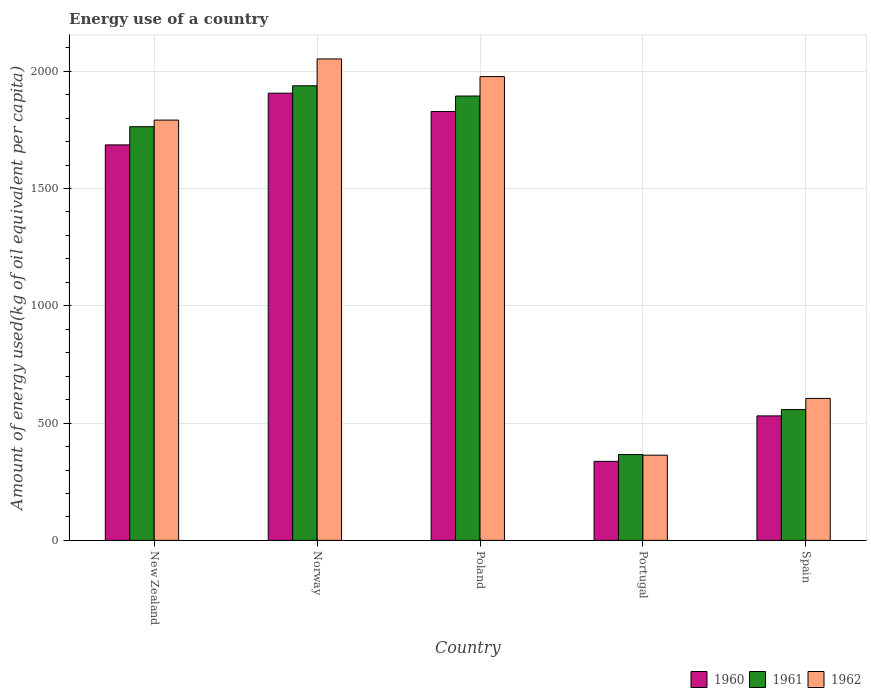How many different coloured bars are there?
Offer a terse response. 3. How many groups of bars are there?
Your answer should be very brief. 5. Are the number of bars per tick equal to the number of legend labels?
Keep it short and to the point. Yes. How many bars are there on the 1st tick from the right?
Give a very brief answer. 3. What is the label of the 4th group of bars from the left?
Offer a very short reply. Portugal. What is the amount of energy used in in 1962 in Poland?
Offer a terse response. 1976.86. Across all countries, what is the maximum amount of energy used in in 1960?
Your response must be concise. 1906.17. Across all countries, what is the minimum amount of energy used in in 1962?
Offer a very short reply. 363.16. In which country was the amount of energy used in in 1961 maximum?
Provide a succinct answer. Norway. In which country was the amount of energy used in in 1961 minimum?
Your answer should be very brief. Portugal. What is the total amount of energy used in in 1962 in the graph?
Keep it short and to the point. 6788.76. What is the difference between the amount of energy used in in 1961 in Norway and that in Spain?
Give a very brief answer. 1380.05. What is the difference between the amount of energy used in in 1962 in Norway and the amount of energy used in in 1960 in New Zealand?
Your response must be concise. 366.27. What is the average amount of energy used in in 1961 per country?
Offer a very short reply. 1303.68. What is the difference between the amount of energy used in of/in 1962 and amount of energy used in of/in 1960 in New Zealand?
Provide a succinct answer. 105.67. In how many countries, is the amount of energy used in in 1961 greater than 1000 kg?
Ensure brevity in your answer.  3. What is the ratio of the amount of energy used in in 1961 in New Zealand to that in Portugal?
Your response must be concise. 4.82. Is the amount of energy used in in 1960 in New Zealand less than that in Portugal?
Your answer should be very brief. No. What is the difference between the highest and the second highest amount of energy used in in 1961?
Your response must be concise. 174.38. What is the difference between the highest and the lowest amount of energy used in in 1961?
Offer a terse response. 1571.8. In how many countries, is the amount of energy used in in 1960 greater than the average amount of energy used in in 1960 taken over all countries?
Offer a terse response. 3. Is the sum of the amount of energy used in in 1962 in New Zealand and Poland greater than the maximum amount of energy used in in 1960 across all countries?
Provide a short and direct response. Yes. Are all the bars in the graph horizontal?
Provide a succinct answer. No. What is the difference between two consecutive major ticks on the Y-axis?
Offer a very short reply. 500. Are the values on the major ticks of Y-axis written in scientific E-notation?
Offer a terse response. No. Does the graph contain any zero values?
Offer a terse response. No. What is the title of the graph?
Your response must be concise. Energy use of a country. Does "1975" appear as one of the legend labels in the graph?
Keep it short and to the point. No. What is the label or title of the X-axis?
Your response must be concise. Country. What is the label or title of the Y-axis?
Offer a terse response. Amount of energy used(kg of oil equivalent per capita). What is the Amount of energy used(kg of oil equivalent per capita) of 1960 in New Zealand?
Your answer should be very brief. 1685.79. What is the Amount of energy used(kg of oil equivalent per capita) of 1961 in New Zealand?
Offer a terse response. 1763.26. What is the Amount of energy used(kg of oil equivalent per capita) of 1962 in New Zealand?
Make the answer very short. 1791.46. What is the Amount of energy used(kg of oil equivalent per capita) of 1960 in Norway?
Provide a short and direct response. 1906.17. What is the Amount of energy used(kg of oil equivalent per capita) of 1961 in Norway?
Provide a succinct answer. 1937.64. What is the Amount of energy used(kg of oil equivalent per capita) of 1962 in Norway?
Make the answer very short. 2052.05. What is the Amount of energy used(kg of oil equivalent per capita) of 1960 in Poland?
Your answer should be compact. 1827.94. What is the Amount of energy used(kg of oil equivalent per capita) of 1961 in Poland?
Your answer should be compact. 1894.06. What is the Amount of energy used(kg of oil equivalent per capita) of 1962 in Poland?
Keep it short and to the point. 1976.86. What is the Amount of energy used(kg of oil equivalent per capita) in 1960 in Portugal?
Offer a terse response. 336.91. What is the Amount of energy used(kg of oil equivalent per capita) of 1961 in Portugal?
Make the answer very short. 365.84. What is the Amount of energy used(kg of oil equivalent per capita) in 1962 in Portugal?
Your answer should be compact. 363.16. What is the Amount of energy used(kg of oil equivalent per capita) of 1960 in Spain?
Your answer should be compact. 530.66. What is the Amount of energy used(kg of oil equivalent per capita) of 1961 in Spain?
Offer a very short reply. 557.6. What is the Amount of energy used(kg of oil equivalent per capita) of 1962 in Spain?
Provide a succinct answer. 605.22. Across all countries, what is the maximum Amount of energy used(kg of oil equivalent per capita) of 1960?
Provide a short and direct response. 1906.17. Across all countries, what is the maximum Amount of energy used(kg of oil equivalent per capita) in 1961?
Ensure brevity in your answer.  1937.64. Across all countries, what is the maximum Amount of energy used(kg of oil equivalent per capita) of 1962?
Make the answer very short. 2052.05. Across all countries, what is the minimum Amount of energy used(kg of oil equivalent per capita) of 1960?
Offer a very short reply. 336.91. Across all countries, what is the minimum Amount of energy used(kg of oil equivalent per capita) of 1961?
Your answer should be very brief. 365.84. Across all countries, what is the minimum Amount of energy used(kg of oil equivalent per capita) of 1962?
Your answer should be very brief. 363.16. What is the total Amount of energy used(kg of oil equivalent per capita) of 1960 in the graph?
Give a very brief answer. 6287.48. What is the total Amount of energy used(kg of oil equivalent per capita) in 1961 in the graph?
Ensure brevity in your answer.  6518.4. What is the total Amount of energy used(kg of oil equivalent per capita) of 1962 in the graph?
Make the answer very short. 6788.76. What is the difference between the Amount of energy used(kg of oil equivalent per capita) in 1960 in New Zealand and that in Norway?
Your response must be concise. -220.39. What is the difference between the Amount of energy used(kg of oil equivalent per capita) in 1961 in New Zealand and that in Norway?
Offer a terse response. -174.38. What is the difference between the Amount of energy used(kg of oil equivalent per capita) in 1962 in New Zealand and that in Norway?
Offer a very short reply. -260.59. What is the difference between the Amount of energy used(kg of oil equivalent per capita) in 1960 in New Zealand and that in Poland?
Your answer should be very brief. -142.15. What is the difference between the Amount of energy used(kg of oil equivalent per capita) in 1961 in New Zealand and that in Poland?
Ensure brevity in your answer.  -130.8. What is the difference between the Amount of energy used(kg of oil equivalent per capita) in 1962 in New Zealand and that in Poland?
Offer a very short reply. -185.4. What is the difference between the Amount of energy used(kg of oil equivalent per capita) of 1960 in New Zealand and that in Portugal?
Give a very brief answer. 1348.87. What is the difference between the Amount of energy used(kg of oil equivalent per capita) of 1961 in New Zealand and that in Portugal?
Provide a short and direct response. 1397.42. What is the difference between the Amount of energy used(kg of oil equivalent per capita) in 1962 in New Zealand and that in Portugal?
Give a very brief answer. 1428.3. What is the difference between the Amount of energy used(kg of oil equivalent per capita) of 1960 in New Zealand and that in Spain?
Your answer should be compact. 1155.12. What is the difference between the Amount of energy used(kg of oil equivalent per capita) of 1961 in New Zealand and that in Spain?
Keep it short and to the point. 1205.66. What is the difference between the Amount of energy used(kg of oil equivalent per capita) of 1962 in New Zealand and that in Spain?
Your response must be concise. 1186.24. What is the difference between the Amount of energy used(kg of oil equivalent per capita) in 1960 in Norway and that in Poland?
Your answer should be very brief. 78.24. What is the difference between the Amount of energy used(kg of oil equivalent per capita) of 1961 in Norway and that in Poland?
Your answer should be compact. 43.59. What is the difference between the Amount of energy used(kg of oil equivalent per capita) of 1962 in Norway and that in Poland?
Offer a very short reply. 75.19. What is the difference between the Amount of energy used(kg of oil equivalent per capita) in 1960 in Norway and that in Portugal?
Ensure brevity in your answer.  1569.26. What is the difference between the Amount of energy used(kg of oil equivalent per capita) in 1961 in Norway and that in Portugal?
Provide a short and direct response. 1571.8. What is the difference between the Amount of energy used(kg of oil equivalent per capita) in 1962 in Norway and that in Portugal?
Make the answer very short. 1688.89. What is the difference between the Amount of energy used(kg of oil equivalent per capita) of 1960 in Norway and that in Spain?
Give a very brief answer. 1375.51. What is the difference between the Amount of energy used(kg of oil equivalent per capita) in 1961 in Norway and that in Spain?
Provide a succinct answer. 1380.05. What is the difference between the Amount of energy used(kg of oil equivalent per capita) of 1962 in Norway and that in Spain?
Provide a short and direct response. 1446.83. What is the difference between the Amount of energy used(kg of oil equivalent per capita) in 1960 in Poland and that in Portugal?
Offer a very short reply. 1491.02. What is the difference between the Amount of energy used(kg of oil equivalent per capita) of 1961 in Poland and that in Portugal?
Provide a succinct answer. 1528.22. What is the difference between the Amount of energy used(kg of oil equivalent per capita) of 1962 in Poland and that in Portugal?
Provide a succinct answer. 1613.7. What is the difference between the Amount of energy used(kg of oil equivalent per capita) in 1960 in Poland and that in Spain?
Your answer should be very brief. 1297.27. What is the difference between the Amount of energy used(kg of oil equivalent per capita) of 1961 in Poland and that in Spain?
Give a very brief answer. 1336.46. What is the difference between the Amount of energy used(kg of oil equivalent per capita) in 1962 in Poland and that in Spain?
Provide a succinct answer. 1371.64. What is the difference between the Amount of energy used(kg of oil equivalent per capita) in 1960 in Portugal and that in Spain?
Offer a terse response. -193.75. What is the difference between the Amount of energy used(kg of oil equivalent per capita) of 1961 in Portugal and that in Spain?
Your answer should be very brief. -191.76. What is the difference between the Amount of energy used(kg of oil equivalent per capita) in 1962 in Portugal and that in Spain?
Make the answer very short. -242.06. What is the difference between the Amount of energy used(kg of oil equivalent per capita) of 1960 in New Zealand and the Amount of energy used(kg of oil equivalent per capita) of 1961 in Norway?
Your answer should be very brief. -251.86. What is the difference between the Amount of energy used(kg of oil equivalent per capita) in 1960 in New Zealand and the Amount of energy used(kg of oil equivalent per capita) in 1962 in Norway?
Provide a succinct answer. -366.27. What is the difference between the Amount of energy used(kg of oil equivalent per capita) of 1961 in New Zealand and the Amount of energy used(kg of oil equivalent per capita) of 1962 in Norway?
Offer a terse response. -288.79. What is the difference between the Amount of energy used(kg of oil equivalent per capita) of 1960 in New Zealand and the Amount of energy used(kg of oil equivalent per capita) of 1961 in Poland?
Make the answer very short. -208.27. What is the difference between the Amount of energy used(kg of oil equivalent per capita) of 1960 in New Zealand and the Amount of energy used(kg of oil equivalent per capita) of 1962 in Poland?
Make the answer very short. -291.07. What is the difference between the Amount of energy used(kg of oil equivalent per capita) in 1961 in New Zealand and the Amount of energy used(kg of oil equivalent per capita) in 1962 in Poland?
Keep it short and to the point. -213.6. What is the difference between the Amount of energy used(kg of oil equivalent per capita) in 1960 in New Zealand and the Amount of energy used(kg of oil equivalent per capita) in 1961 in Portugal?
Keep it short and to the point. 1319.95. What is the difference between the Amount of energy used(kg of oil equivalent per capita) of 1960 in New Zealand and the Amount of energy used(kg of oil equivalent per capita) of 1962 in Portugal?
Your answer should be compact. 1322.62. What is the difference between the Amount of energy used(kg of oil equivalent per capita) of 1961 in New Zealand and the Amount of energy used(kg of oil equivalent per capita) of 1962 in Portugal?
Ensure brevity in your answer.  1400.1. What is the difference between the Amount of energy used(kg of oil equivalent per capita) in 1960 in New Zealand and the Amount of energy used(kg of oil equivalent per capita) in 1961 in Spain?
Make the answer very short. 1128.19. What is the difference between the Amount of energy used(kg of oil equivalent per capita) of 1960 in New Zealand and the Amount of energy used(kg of oil equivalent per capita) of 1962 in Spain?
Ensure brevity in your answer.  1080.56. What is the difference between the Amount of energy used(kg of oil equivalent per capita) in 1961 in New Zealand and the Amount of energy used(kg of oil equivalent per capita) in 1962 in Spain?
Keep it short and to the point. 1158.04. What is the difference between the Amount of energy used(kg of oil equivalent per capita) of 1960 in Norway and the Amount of energy used(kg of oil equivalent per capita) of 1961 in Poland?
Ensure brevity in your answer.  12.12. What is the difference between the Amount of energy used(kg of oil equivalent per capita) in 1960 in Norway and the Amount of energy used(kg of oil equivalent per capita) in 1962 in Poland?
Keep it short and to the point. -70.68. What is the difference between the Amount of energy used(kg of oil equivalent per capita) in 1961 in Norway and the Amount of energy used(kg of oil equivalent per capita) in 1962 in Poland?
Keep it short and to the point. -39.22. What is the difference between the Amount of energy used(kg of oil equivalent per capita) of 1960 in Norway and the Amount of energy used(kg of oil equivalent per capita) of 1961 in Portugal?
Make the answer very short. 1540.33. What is the difference between the Amount of energy used(kg of oil equivalent per capita) of 1960 in Norway and the Amount of energy used(kg of oil equivalent per capita) of 1962 in Portugal?
Make the answer very short. 1543.01. What is the difference between the Amount of energy used(kg of oil equivalent per capita) in 1961 in Norway and the Amount of energy used(kg of oil equivalent per capita) in 1962 in Portugal?
Your response must be concise. 1574.48. What is the difference between the Amount of energy used(kg of oil equivalent per capita) in 1960 in Norway and the Amount of energy used(kg of oil equivalent per capita) in 1961 in Spain?
Keep it short and to the point. 1348.58. What is the difference between the Amount of energy used(kg of oil equivalent per capita) in 1960 in Norway and the Amount of energy used(kg of oil equivalent per capita) in 1962 in Spain?
Your response must be concise. 1300.95. What is the difference between the Amount of energy used(kg of oil equivalent per capita) in 1961 in Norway and the Amount of energy used(kg of oil equivalent per capita) in 1962 in Spain?
Your answer should be very brief. 1332.42. What is the difference between the Amount of energy used(kg of oil equivalent per capita) of 1960 in Poland and the Amount of energy used(kg of oil equivalent per capita) of 1961 in Portugal?
Provide a short and direct response. 1462.1. What is the difference between the Amount of energy used(kg of oil equivalent per capita) of 1960 in Poland and the Amount of energy used(kg of oil equivalent per capita) of 1962 in Portugal?
Offer a very short reply. 1464.77. What is the difference between the Amount of energy used(kg of oil equivalent per capita) of 1961 in Poland and the Amount of energy used(kg of oil equivalent per capita) of 1962 in Portugal?
Offer a terse response. 1530.89. What is the difference between the Amount of energy used(kg of oil equivalent per capita) of 1960 in Poland and the Amount of energy used(kg of oil equivalent per capita) of 1961 in Spain?
Your answer should be very brief. 1270.34. What is the difference between the Amount of energy used(kg of oil equivalent per capita) in 1960 in Poland and the Amount of energy used(kg of oil equivalent per capita) in 1962 in Spain?
Make the answer very short. 1222.71. What is the difference between the Amount of energy used(kg of oil equivalent per capita) of 1961 in Poland and the Amount of energy used(kg of oil equivalent per capita) of 1962 in Spain?
Make the answer very short. 1288.83. What is the difference between the Amount of energy used(kg of oil equivalent per capita) in 1960 in Portugal and the Amount of energy used(kg of oil equivalent per capita) in 1961 in Spain?
Offer a very short reply. -220.69. What is the difference between the Amount of energy used(kg of oil equivalent per capita) in 1960 in Portugal and the Amount of energy used(kg of oil equivalent per capita) in 1962 in Spain?
Keep it short and to the point. -268.31. What is the difference between the Amount of energy used(kg of oil equivalent per capita) of 1961 in Portugal and the Amount of energy used(kg of oil equivalent per capita) of 1962 in Spain?
Ensure brevity in your answer.  -239.38. What is the average Amount of energy used(kg of oil equivalent per capita) in 1960 per country?
Give a very brief answer. 1257.5. What is the average Amount of energy used(kg of oil equivalent per capita) in 1961 per country?
Make the answer very short. 1303.68. What is the average Amount of energy used(kg of oil equivalent per capita) in 1962 per country?
Ensure brevity in your answer.  1357.75. What is the difference between the Amount of energy used(kg of oil equivalent per capita) in 1960 and Amount of energy used(kg of oil equivalent per capita) in 1961 in New Zealand?
Your answer should be very brief. -77.47. What is the difference between the Amount of energy used(kg of oil equivalent per capita) of 1960 and Amount of energy used(kg of oil equivalent per capita) of 1962 in New Zealand?
Give a very brief answer. -105.67. What is the difference between the Amount of energy used(kg of oil equivalent per capita) in 1961 and Amount of energy used(kg of oil equivalent per capita) in 1962 in New Zealand?
Keep it short and to the point. -28.2. What is the difference between the Amount of energy used(kg of oil equivalent per capita) in 1960 and Amount of energy used(kg of oil equivalent per capita) in 1961 in Norway?
Provide a succinct answer. -31.47. What is the difference between the Amount of energy used(kg of oil equivalent per capita) of 1960 and Amount of energy used(kg of oil equivalent per capita) of 1962 in Norway?
Provide a short and direct response. -145.88. What is the difference between the Amount of energy used(kg of oil equivalent per capita) of 1961 and Amount of energy used(kg of oil equivalent per capita) of 1962 in Norway?
Offer a terse response. -114.41. What is the difference between the Amount of energy used(kg of oil equivalent per capita) of 1960 and Amount of energy used(kg of oil equivalent per capita) of 1961 in Poland?
Your response must be concise. -66.12. What is the difference between the Amount of energy used(kg of oil equivalent per capita) in 1960 and Amount of energy used(kg of oil equivalent per capita) in 1962 in Poland?
Offer a very short reply. -148.92. What is the difference between the Amount of energy used(kg of oil equivalent per capita) of 1961 and Amount of energy used(kg of oil equivalent per capita) of 1962 in Poland?
Ensure brevity in your answer.  -82.8. What is the difference between the Amount of energy used(kg of oil equivalent per capita) in 1960 and Amount of energy used(kg of oil equivalent per capita) in 1961 in Portugal?
Your answer should be very brief. -28.93. What is the difference between the Amount of energy used(kg of oil equivalent per capita) of 1960 and Amount of energy used(kg of oil equivalent per capita) of 1962 in Portugal?
Your response must be concise. -26.25. What is the difference between the Amount of energy used(kg of oil equivalent per capita) of 1961 and Amount of energy used(kg of oil equivalent per capita) of 1962 in Portugal?
Your response must be concise. 2.68. What is the difference between the Amount of energy used(kg of oil equivalent per capita) of 1960 and Amount of energy used(kg of oil equivalent per capita) of 1961 in Spain?
Your answer should be compact. -26.93. What is the difference between the Amount of energy used(kg of oil equivalent per capita) in 1960 and Amount of energy used(kg of oil equivalent per capita) in 1962 in Spain?
Your answer should be very brief. -74.56. What is the difference between the Amount of energy used(kg of oil equivalent per capita) of 1961 and Amount of energy used(kg of oil equivalent per capita) of 1962 in Spain?
Offer a very short reply. -47.62. What is the ratio of the Amount of energy used(kg of oil equivalent per capita) in 1960 in New Zealand to that in Norway?
Your answer should be very brief. 0.88. What is the ratio of the Amount of energy used(kg of oil equivalent per capita) of 1961 in New Zealand to that in Norway?
Your response must be concise. 0.91. What is the ratio of the Amount of energy used(kg of oil equivalent per capita) in 1962 in New Zealand to that in Norway?
Provide a short and direct response. 0.87. What is the ratio of the Amount of energy used(kg of oil equivalent per capita) in 1960 in New Zealand to that in Poland?
Give a very brief answer. 0.92. What is the ratio of the Amount of energy used(kg of oil equivalent per capita) of 1961 in New Zealand to that in Poland?
Provide a short and direct response. 0.93. What is the ratio of the Amount of energy used(kg of oil equivalent per capita) in 1962 in New Zealand to that in Poland?
Provide a short and direct response. 0.91. What is the ratio of the Amount of energy used(kg of oil equivalent per capita) in 1960 in New Zealand to that in Portugal?
Give a very brief answer. 5. What is the ratio of the Amount of energy used(kg of oil equivalent per capita) of 1961 in New Zealand to that in Portugal?
Your response must be concise. 4.82. What is the ratio of the Amount of energy used(kg of oil equivalent per capita) of 1962 in New Zealand to that in Portugal?
Provide a succinct answer. 4.93. What is the ratio of the Amount of energy used(kg of oil equivalent per capita) of 1960 in New Zealand to that in Spain?
Ensure brevity in your answer.  3.18. What is the ratio of the Amount of energy used(kg of oil equivalent per capita) in 1961 in New Zealand to that in Spain?
Offer a terse response. 3.16. What is the ratio of the Amount of energy used(kg of oil equivalent per capita) in 1962 in New Zealand to that in Spain?
Provide a short and direct response. 2.96. What is the ratio of the Amount of energy used(kg of oil equivalent per capita) in 1960 in Norway to that in Poland?
Keep it short and to the point. 1.04. What is the ratio of the Amount of energy used(kg of oil equivalent per capita) of 1962 in Norway to that in Poland?
Make the answer very short. 1.04. What is the ratio of the Amount of energy used(kg of oil equivalent per capita) of 1960 in Norway to that in Portugal?
Ensure brevity in your answer.  5.66. What is the ratio of the Amount of energy used(kg of oil equivalent per capita) in 1961 in Norway to that in Portugal?
Offer a very short reply. 5.3. What is the ratio of the Amount of energy used(kg of oil equivalent per capita) in 1962 in Norway to that in Portugal?
Your response must be concise. 5.65. What is the ratio of the Amount of energy used(kg of oil equivalent per capita) of 1960 in Norway to that in Spain?
Your answer should be compact. 3.59. What is the ratio of the Amount of energy used(kg of oil equivalent per capita) of 1961 in Norway to that in Spain?
Ensure brevity in your answer.  3.48. What is the ratio of the Amount of energy used(kg of oil equivalent per capita) of 1962 in Norway to that in Spain?
Your answer should be very brief. 3.39. What is the ratio of the Amount of energy used(kg of oil equivalent per capita) in 1960 in Poland to that in Portugal?
Provide a succinct answer. 5.43. What is the ratio of the Amount of energy used(kg of oil equivalent per capita) in 1961 in Poland to that in Portugal?
Make the answer very short. 5.18. What is the ratio of the Amount of energy used(kg of oil equivalent per capita) in 1962 in Poland to that in Portugal?
Your response must be concise. 5.44. What is the ratio of the Amount of energy used(kg of oil equivalent per capita) of 1960 in Poland to that in Spain?
Offer a very short reply. 3.44. What is the ratio of the Amount of energy used(kg of oil equivalent per capita) of 1961 in Poland to that in Spain?
Your answer should be very brief. 3.4. What is the ratio of the Amount of energy used(kg of oil equivalent per capita) in 1962 in Poland to that in Spain?
Provide a succinct answer. 3.27. What is the ratio of the Amount of energy used(kg of oil equivalent per capita) in 1960 in Portugal to that in Spain?
Your response must be concise. 0.63. What is the ratio of the Amount of energy used(kg of oil equivalent per capita) in 1961 in Portugal to that in Spain?
Your response must be concise. 0.66. What is the difference between the highest and the second highest Amount of energy used(kg of oil equivalent per capita) in 1960?
Keep it short and to the point. 78.24. What is the difference between the highest and the second highest Amount of energy used(kg of oil equivalent per capita) in 1961?
Your answer should be very brief. 43.59. What is the difference between the highest and the second highest Amount of energy used(kg of oil equivalent per capita) in 1962?
Give a very brief answer. 75.19. What is the difference between the highest and the lowest Amount of energy used(kg of oil equivalent per capita) of 1960?
Provide a short and direct response. 1569.26. What is the difference between the highest and the lowest Amount of energy used(kg of oil equivalent per capita) of 1961?
Provide a short and direct response. 1571.8. What is the difference between the highest and the lowest Amount of energy used(kg of oil equivalent per capita) in 1962?
Provide a short and direct response. 1688.89. 